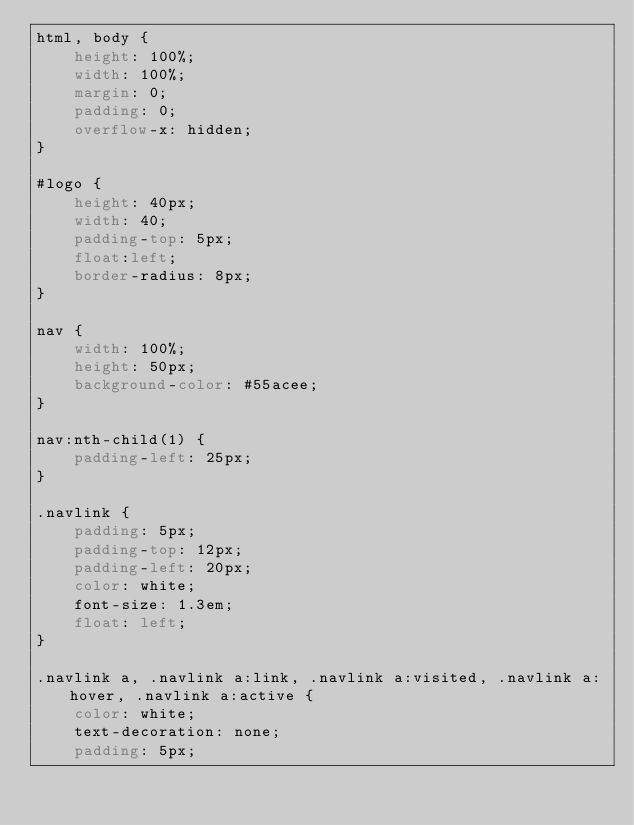<code> <loc_0><loc_0><loc_500><loc_500><_CSS_>html, body {
    height: 100%;
    width: 100%;
    margin: 0;
    padding: 0;
    overflow-x: hidden;
}

#logo {
    height: 40px;
    width: 40;
    padding-top: 5px;
    float:left;
    border-radius: 8px;
}

nav {
    width: 100%;
    height: 50px;
    background-color: #55acee;
}

nav:nth-child(1) {
    padding-left: 25px;
}

.navlink {
    padding: 5px;
    padding-top: 12px;
    padding-left: 20px;
    color: white;
    font-size: 1.3em;
    float: left;
}

.navlink a, .navlink a:link, .navlink a:visited, .navlink a:hover, .navlink a:active {
    color: white;
    text-decoration: none;
    padding: 5px;</code> 